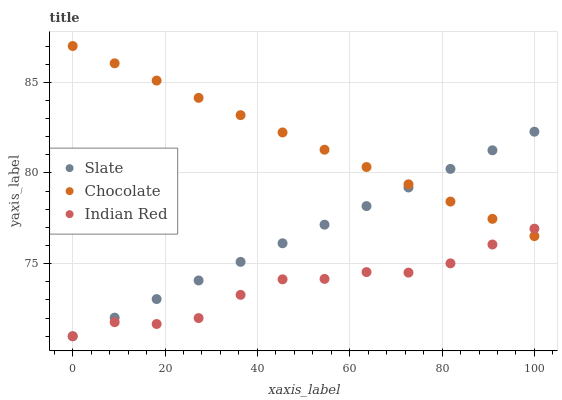Does Indian Red have the minimum area under the curve?
Answer yes or no. Yes. Does Chocolate have the maximum area under the curve?
Answer yes or no. Yes. Does Chocolate have the minimum area under the curve?
Answer yes or no. No. Does Indian Red have the maximum area under the curve?
Answer yes or no. No. Is Slate the smoothest?
Answer yes or no. Yes. Is Indian Red the roughest?
Answer yes or no. Yes. Is Chocolate the smoothest?
Answer yes or no. No. Is Chocolate the roughest?
Answer yes or no. No. Does Slate have the lowest value?
Answer yes or no. Yes. Does Chocolate have the lowest value?
Answer yes or no. No. Does Chocolate have the highest value?
Answer yes or no. Yes. Does Indian Red have the highest value?
Answer yes or no. No. Does Chocolate intersect Indian Red?
Answer yes or no. Yes. Is Chocolate less than Indian Red?
Answer yes or no. No. Is Chocolate greater than Indian Red?
Answer yes or no. No. 